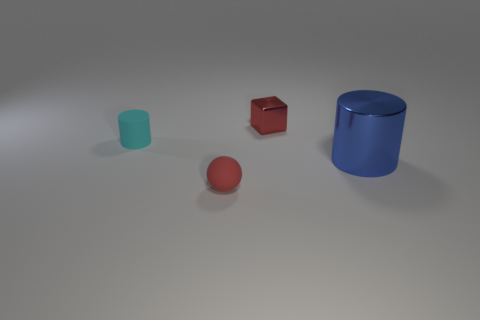What is the size of the cyan matte thing that is the same shape as the big blue object?
Keep it short and to the point. Small. Is there anything else that is made of the same material as the red sphere?
Give a very brief answer. Yes. The large blue shiny object is what shape?
Offer a very short reply. Cylinder. What shape is the cyan thing that is the same size as the red cube?
Provide a short and direct response. Cylinder. Is there anything else that is the same color as the tiny cylinder?
Keep it short and to the point. No. What size is the thing that is the same material as the block?
Offer a terse response. Large. Is the shape of the big metal thing the same as the red thing on the right side of the red rubber ball?
Provide a short and direct response. No. The cyan cylinder has what size?
Your answer should be very brief. Small. Are there fewer tiny matte objects that are in front of the big metal cylinder than small cyan rubber cylinders?
Provide a short and direct response. No. How many objects have the same size as the cube?
Ensure brevity in your answer.  2. 